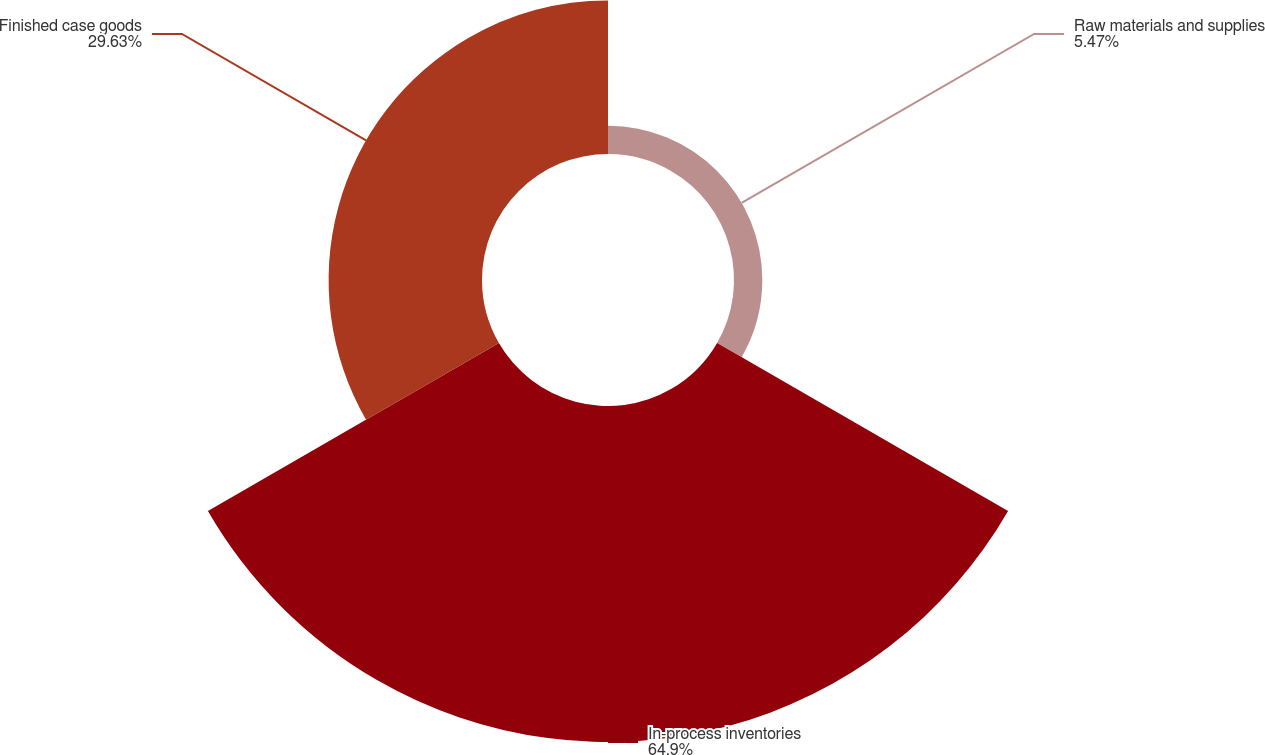Convert chart. <chart><loc_0><loc_0><loc_500><loc_500><pie_chart><fcel>Raw materials and supplies<fcel>In-process inventories<fcel>Finished case goods<nl><fcel>5.47%<fcel>64.9%<fcel>29.63%<nl></chart> 